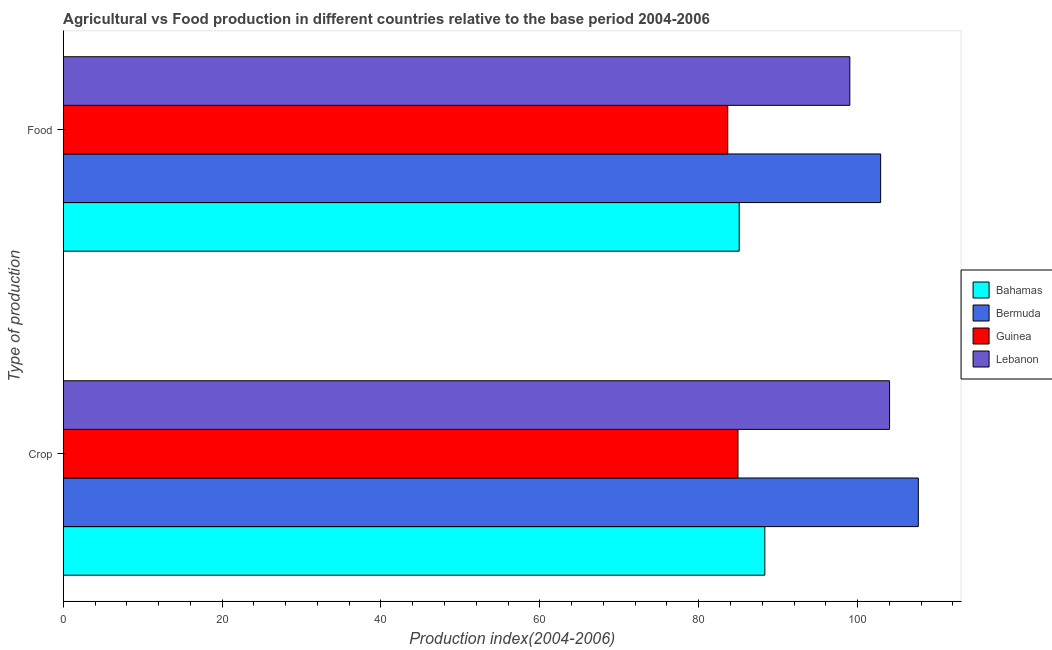How many different coloured bars are there?
Ensure brevity in your answer.  4. How many groups of bars are there?
Keep it short and to the point. 2. What is the label of the 1st group of bars from the top?
Ensure brevity in your answer.  Food. What is the crop production index in Bahamas?
Provide a succinct answer. 88.32. Across all countries, what is the maximum food production index?
Make the answer very short. 102.9. Across all countries, what is the minimum food production index?
Your answer should be compact. 83.65. In which country was the food production index maximum?
Keep it short and to the point. Bermuda. In which country was the food production index minimum?
Offer a terse response. Guinea. What is the total crop production index in the graph?
Keep it short and to the point. 384.92. What is the difference between the food production index in Lebanon and that in Bahamas?
Your answer should be very brief. 13.93. What is the difference between the food production index in Lebanon and the crop production index in Bahamas?
Keep it short and to the point. 10.7. What is the average crop production index per country?
Provide a short and direct response. 96.23. What is the difference between the food production index and crop production index in Bahamas?
Your response must be concise. -3.23. In how many countries, is the food production index greater than 40 ?
Make the answer very short. 4. What is the ratio of the food production index in Guinea to that in Bermuda?
Your answer should be very brief. 0.81. What does the 1st bar from the top in Food represents?
Make the answer very short. Lebanon. What does the 4th bar from the bottom in Crop represents?
Give a very brief answer. Lebanon. Are all the bars in the graph horizontal?
Provide a succinct answer. Yes. How many countries are there in the graph?
Provide a short and direct response. 4. What is the difference between two consecutive major ticks on the X-axis?
Keep it short and to the point. 20. Does the graph contain any zero values?
Provide a short and direct response. No. Does the graph contain grids?
Offer a very short reply. No. What is the title of the graph?
Ensure brevity in your answer.  Agricultural vs Food production in different countries relative to the base period 2004-2006. What is the label or title of the X-axis?
Your answer should be compact. Production index(2004-2006). What is the label or title of the Y-axis?
Offer a very short reply. Type of production. What is the Production index(2004-2006) in Bahamas in Crop?
Your answer should be very brief. 88.32. What is the Production index(2004-2006) in Bermuda in Crop?
Your answer should be compact. 107.64. What is the Production index(2004-2006) in Guinea in Crop?
Your response must be concise. 84.94. What is the Production index(2004-2006) of Lebanon in Crop?
Make the answer very short. 104.02. What is the Production index(2004-2006) of Bahamas in Food?
Ensure brevity in your answer.  85.09. What is the Production index(2004-2006) in Bermuda in Food?
Ensure brevity in your answer.  102.9. What is the Production index(2004-2006) in Guinea in Food?
Offer a very short reply. 83.65. What is the Production index(2004-2006) in Lebanon in Food?
Offer a very short reply. 99.02. Across all Type of production, what is the maximum Production index(2004-2006) of Bahamas?
Provide a succinct answer. 88.32. Across all Type of production, what is the maximum Production index(2004-2006) in Bermuda?
Your response must be concise. 107.64. Across all Type of production, what is the maximum Production index(2004-2006) of Guinea?
Give a very brief answer. 84.94. Across all Type of production, what is the maximum Production index(2004-2006) of Lebanon?
Your response must be concise. 104.02. Across all Type of production, what is the minimum Production index(2004-2006) of Bahamas?
Offer a very short reply. 85.09. Across all Type of production, what is the minimum Production index(2004-2006) of Bermuda?
Give a very brief answer. 102.9. Across all Type of production, what is the minimum Production index(2004-2006) of Guinea?
Keep it short and to the point. 83.65. Across all Type of production, what is the minimum Production index(2004-2006) of Lebanon?
Offer a very short reply. 99.02. What is the total Production index(2004-2006) in Bahamas in the graph?
Offer a terse response. 173.41. What is the total Production index(2004-2006) of Bermuda in the graph?
Offer a terse response. 210.54. What is the total Production index(2004-2006) in Guinea in the graph?
Offer a terse response. 168.59. What is the total Production index(2004-2006) of Lebanon in the graph?
Your answer should be very brief. 203.04. What is the difference between the Production index(2004-2006) in Bahamas in Crop and that in Food?
Ensure brevity in your answer.  3.23. What is the difference between the Production index(2004-2006) in Bermuda in Crop and that in Food?
Your answer should be compact. 4.74. What is the difference between the Production index(2004-2006) of Guinea in Crop and that in Food?
Offer a very short reply. 1.29. What is the difference between the Production index(2004-2006) in Lebanon in Crop and that in Food?
Give a very brief answer. 5. What is the difference between the Production index(2004-2006) of Bahamas in Crop and the Production index(2004-2006) of Bermuda in Food?
Give a very brief answer. -14.58. What is the difference between the Production index(2004-2006) of Bahamas in Crop and the Production index(2004-2006) of Guinea in Food?
Offer a terse response. 4.67. What is the difference between the Production index(2004-2006) in Bahamas in Crop and the Production index(2004-2006) in Lebanon in Food?
Your answer should be very brief. -10.7. What is the difference between the Production index(2004-2006) in Bermuda in Crop and the Production index(2004-2006) in Guinea in Food?
Make the answer very short. 23.99. What is the difference between the Production index(2004-2006) in Bermuda in Crop and the Production index(2004-2006) in Lebanon in Food?
Provide a short and direct response. 8.62. What is the difference between the Production index(2004-2006) in Guinea in Crop and the Production index(2004-2006) in Lebanon in Food?
Your answer should be compact. -14.08. What is the average Production index(2004-2006) in Bahamas per Type of production?
Ensure brevity in your answer.  86.7. What is the average Production index(2004-2006) in Bermuda per Type of production?
Offer a terse response. 105.27. What is the average Production index(2004-2006) of Guinea per Type of production?
Ensure brevity in your answer.  84.3. What is the average Production index(2004-2006) in Lebanon per Type of production?
Your answer should be compact. 101.52. What is the difference between the Production index(2004-2006) in Bahamas and Production index(2004-2006) in Bermuda in Crop?
Your response must be concise. -19.32. What is the difference between the Production index(2004-2006) of Bahamas and Production index(2004-2006) of Guinea in Crop?
Give a very brief answer. 3.38. What is the difference between the Production index(2004-2006) of Bahamas and Production index(2004-2006) of Lebanon in Crop?
Ensure brevity in your answer.  -15.7. What is the difference between the Production index(2004-2006) of Bermuda and Production index(2004-2006) of Guinea in Crop?
Provide a succinct answer. 22.7. What is the difference between the Production index(2004-2006) in Bermuda and Production index(2004-2006) in Lebanon in Crop?
Ensure brevity in your answer.  3.62. What is the difference between the Production index(2004-2006) of Guinea and Production index(2004-2006) of Lebanon in Crop?
Your answer should be compact. -19.08. What is the difference between the Production index(2004-2006) of Bahamas and Production index(2004-2006) of Bermuda in Food?
Provide a succinct answer. -17.81. What is the difference between the Production index(2004-2006) in Bahamas and Production index(2004-2006) in Guinea in Food?
Make the answer very short. 1.44. What is the difference between the Production index(2004-2006) of Bahamas and Production index(2004-2006) of Lebanon in Food?
Provide a succinct answer. -13.93. What is the difference between the Production index(2004-2006) in Bermuda and Production index(2004-2006) in Guinea in Food?
Ensure brevity in your answer.  19.25. What is the difference between the Production index(2004-2006) in Bermuda and Production index(2004-2006) in Lebanon in Food?
Offer a terse response. 3.88. What is the difference between the Production index(2004-2006) in Guinea and Production index(2004-2006) in Lebanon in Food?
Provide a short and direct response. -15.37. What is the ratio of the Production index(2004-2006) in Bahamas in Crop to that in Food?
Ensure brevity in your answer.  1.04. What is the ratio of the Production index(2004-2006) in Bermuda in Crop to that in Food?
Make the answer very short. 1.05. What is the ratio of the Production index(2004-2006) of Guinea in Crop to that in Food?
Keep it short and to the point. 1.02. What is the ratio of the Production index(2004-2006) of Lebanon in Crop to that in Food?
Make the answer very short. 1.05. What is the difference between the highest and the second highest Production index(2004-2006) of Bahamas?
Your answer should be compact. 3.23. What is the difference between the highest and the second highest Production index(2004-2006) of Bermuda?
Provide a short and direct response. 4.74. What is the difference between the highest and the second highest Production index(2004-2006) in Guinea?
Offer a terse response. 1.29. What is the difference between the highest and the second highest Production index(2004-2006) in Lebanon?
Offer a terse response. 5. What is the difference between the highest and the lowest Production index(2004-2006) of Bahamas?
Offer a terse response. 3.23. What is the difference between the highest and the lowest Production index(2004-2006) of Bermuda?
Ensure brevity in your answer.  4.74. What is the difference between the highest and the lowest Production index(2004-2006) in Guinea?
Offer a very short reply. 1.29. 